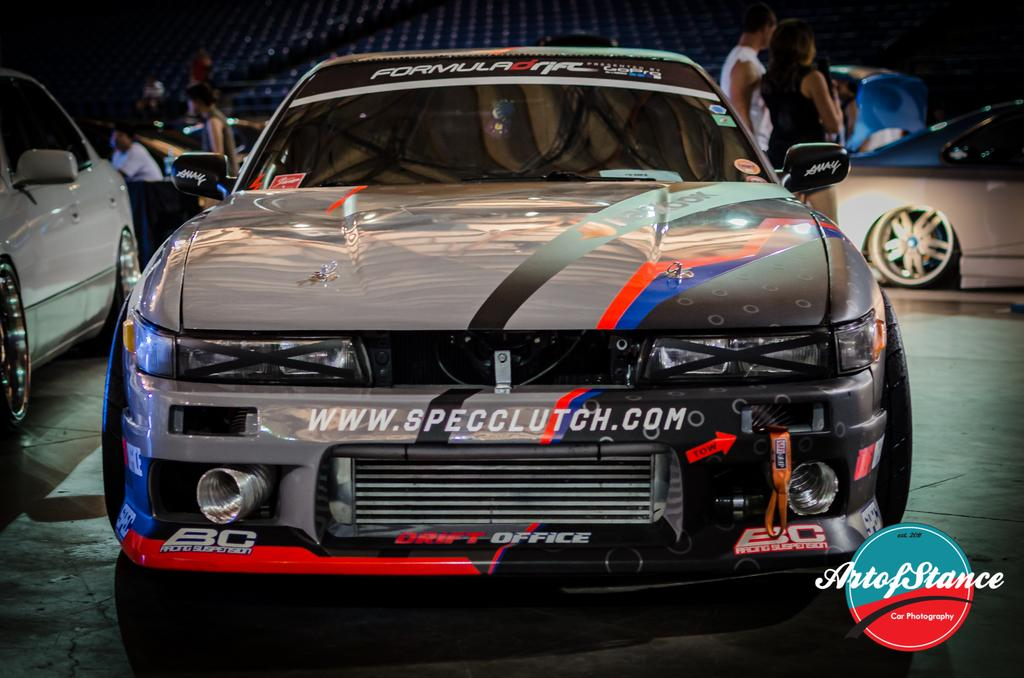What is the main subject of focus of the image? There is a car in the center of the image. What can be seen in the background of the image? There are people and other cars in the background of the image. What is located at the bottom of the image? There is a logo and a road at the bottom of the image. What type of throne is depicted in the image? There is no throne present in the image. What order is being followed by the people in the image? The image does not depict any specific order or sequence of actions. 